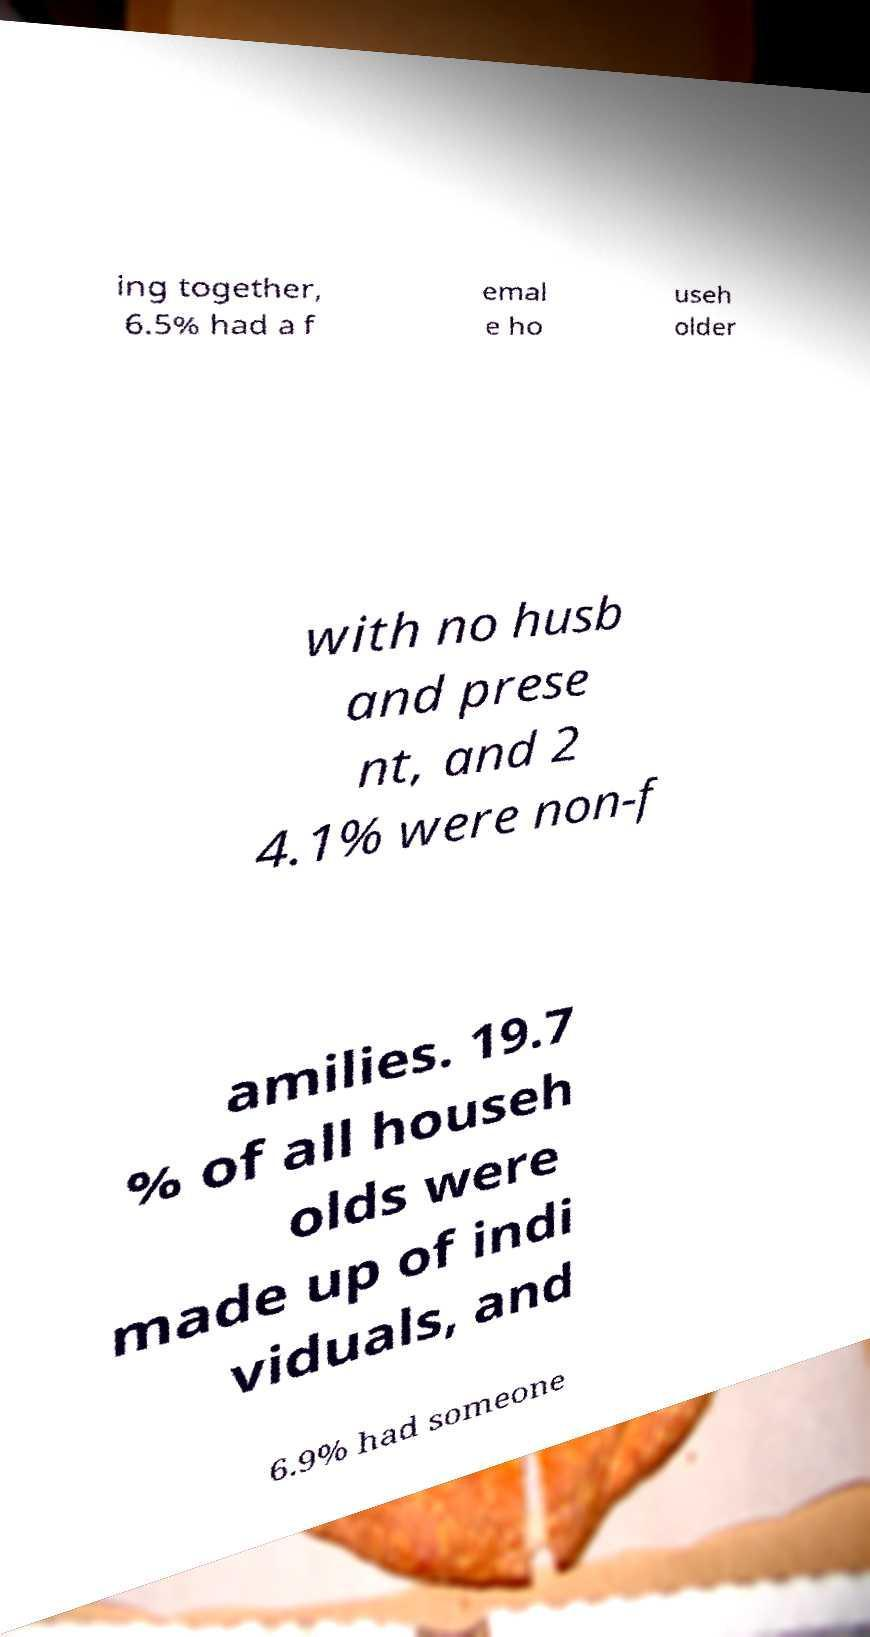For documentation purposes, I need the text within this image transcribed. Could you provide that? ing together, 6.5% had a f emal e ho useh older with no husb and prese nt, and 2 4.1% were non-f amilies. 19.7 % of all househ olds were made up of indi viduals, and 6.9% had someone 